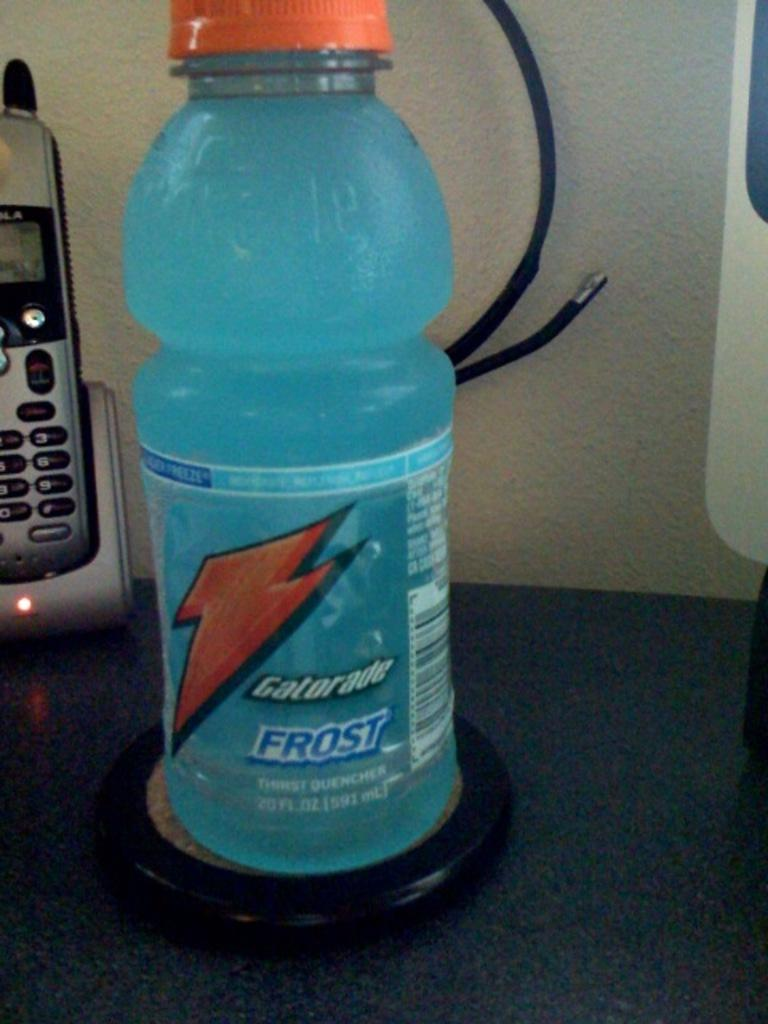<image>
Provide a brief description of the given image. A full bottle of Gatorade Frost next to a phone. 